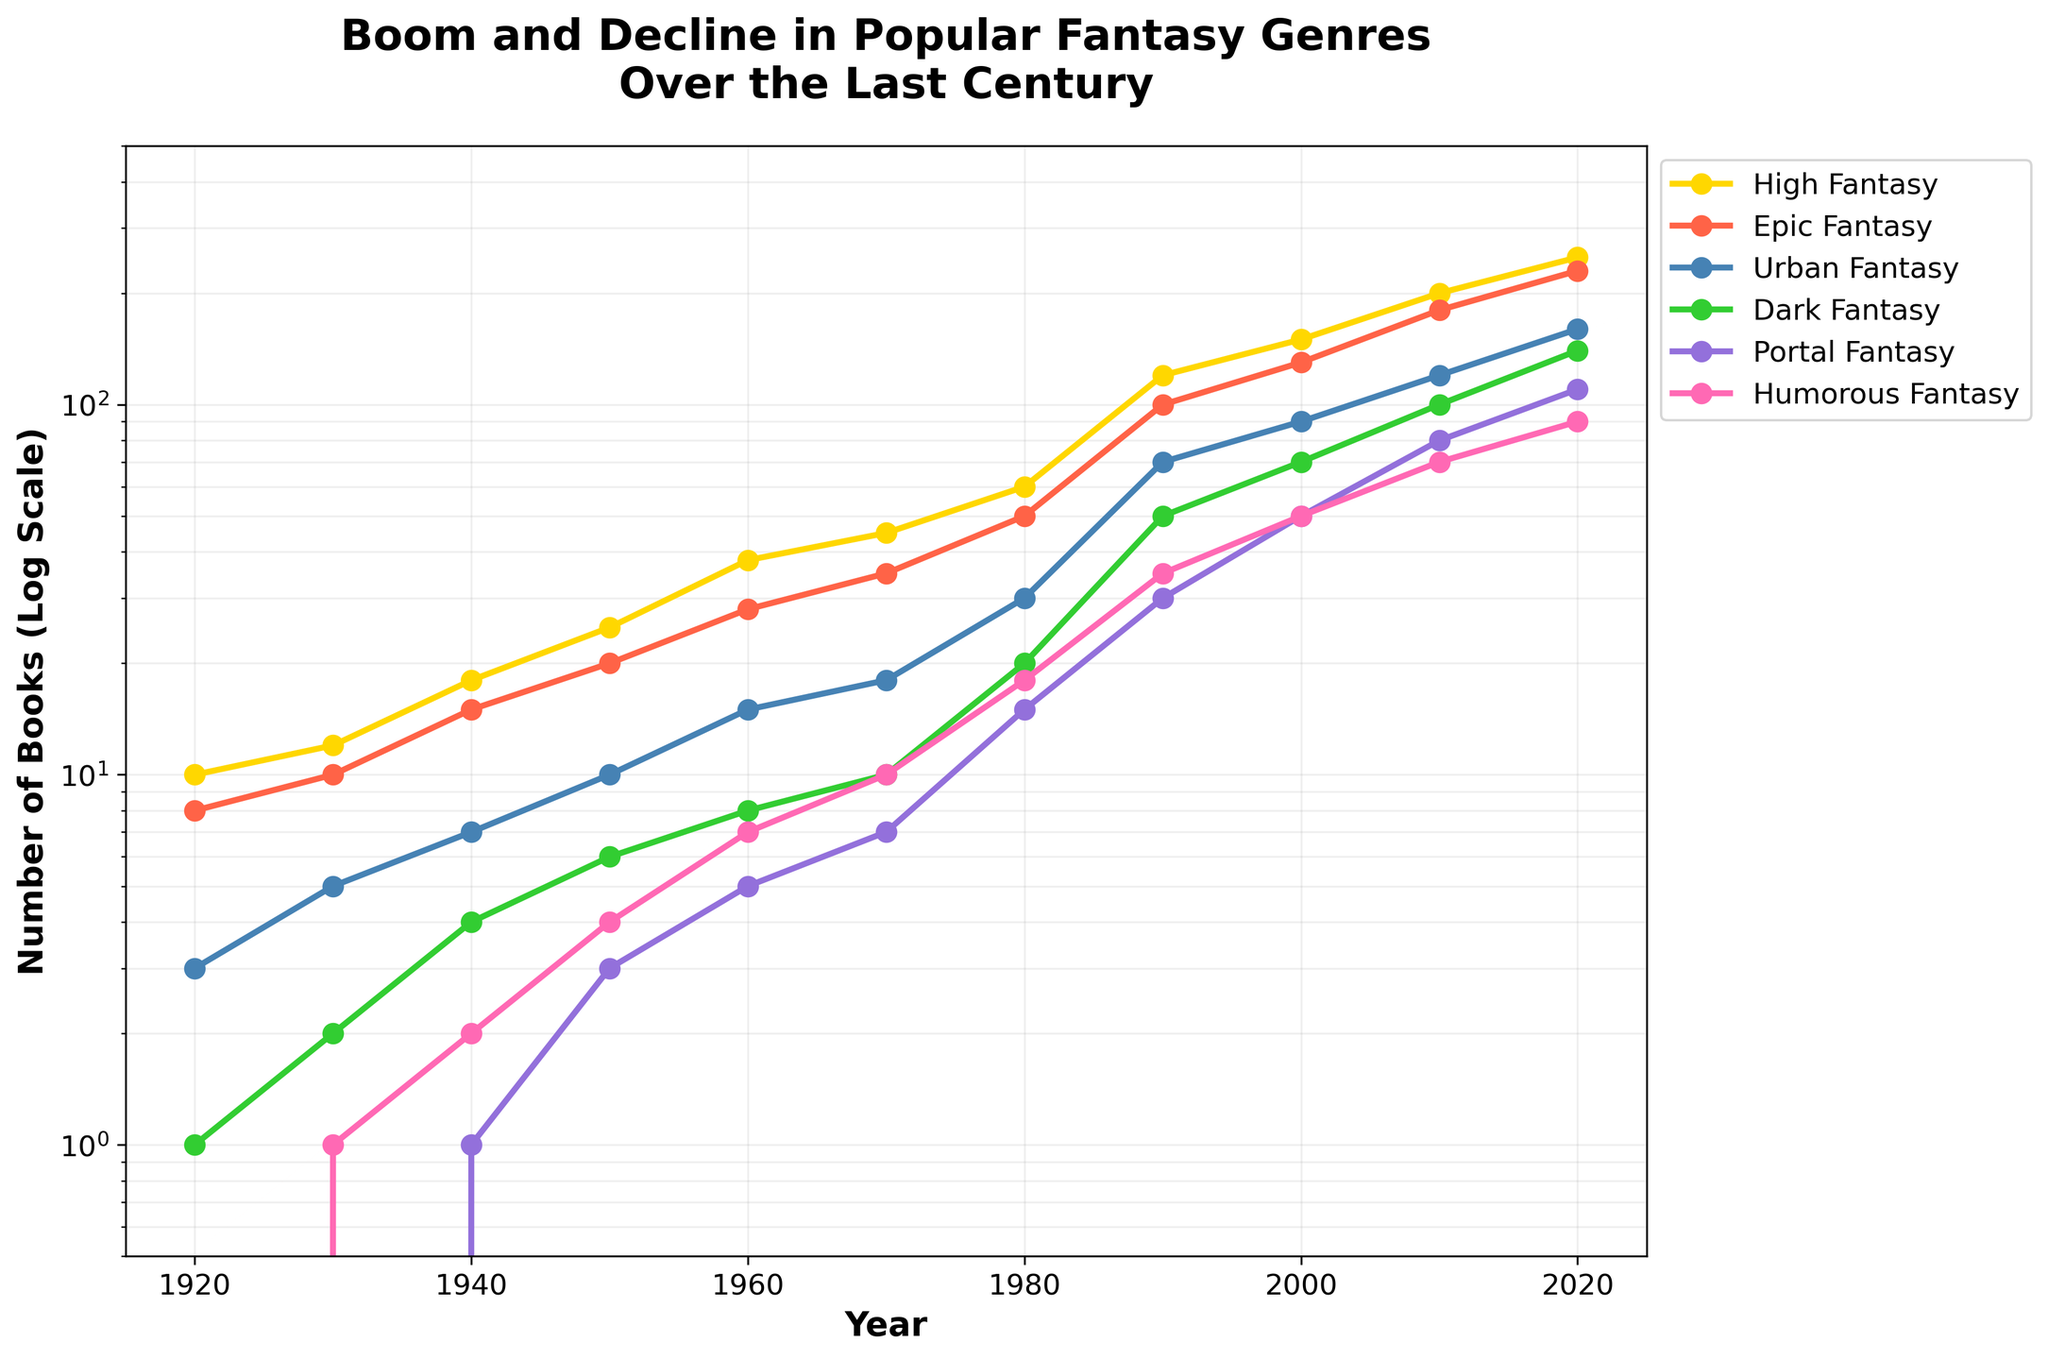What does the title of the figure say? The title of the figure is located at the top. It reads "Boom and Decline in Popular Fantasy Genres Over the Last Century."
Answer: Boom and Decline in Popular Fantasy Genres Over the Last Century What are the x-axis and y-axis labeled as? The x-axis label is found at the bottom of the figure, reading "Year." The y-axis label, located on the left side, reads "Number of Books (Log Scale)."
Answer: Year; Number of Books (Log Scale) Which sub-genre shows the highest value in 2020? As indicated by examining the data points at 2020, "High Fantasy" reaches the highest value among the sub-genres.
Answer: High Fantasy What range does the y-axis cover? The y-axis ranges logarithmically from 0.5 to 500, as observed from the scale on the y-axis.
Answer: 0.5 to 500 How many sub-genres are displayed in this figure? By identifying the lines and their corresponding labels in the legend, there are six sub-genres shown.
Answer: Six Which sub-genre shows the largest growth from 1920 to 2020? By comparing the values from 1920 to 2020 for each sub-genre, "High Fantasy" exhibits the most significant increase.
Answer: High Fantasy In what year does "Urban Fantasy" first reach 100 books? By tracing the "Urban Fantasy" line (colored uniquely) along the x-axis, the year it surpasses 100 books is around 2010.
Answer: 2010 Which sub-genre shows a steady increase without decline over the century? Observing each line's trend, all listed sub-genres show a continuous increase, with no apparent declines over the period.
Answer: All sub-genres What is the difference between "High Fantasy" and "Dark Fantasy" in 2000? In 2000, "High Fantasy" has a value of 150, and "Dark Fantasy" has 70. The difference is 150 - 70 = 80.
Answer: 80 Which sub-genre had a significant rise between 1990 and 2000? Comparing values in 1990 and 2000, "Urban Fantasy" increased from 70 to 90. Although all sub-genres showed growth, "Urban Fantasy" had a notable rise.
Answer: Urban Fantasy 